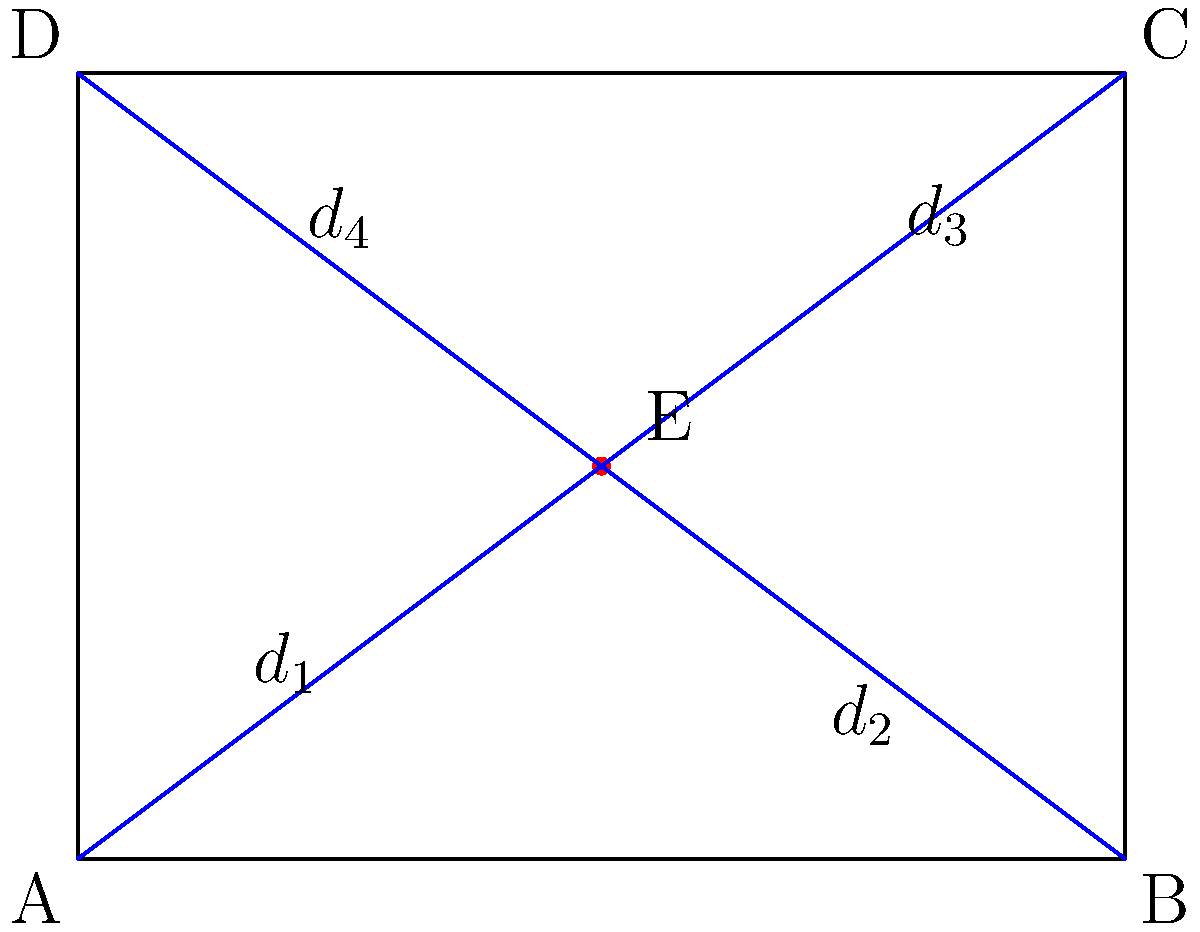You're planning to capture a panoramic view of a rectangular area using your RC aircraft equipped with open-source flight control software. The area measures 4 units wide and 3 units long. To ensure optimal coverage, you want to position your drone at a point E inside the rectangle that minimizes the sum of distances to all four corners. What are the coordinates of point E? To solve this problem, we'll follow these steps:

1) First, we need to understand that the point E we're looking for is the geometric median of the rectangle, also known as the Fermat point.

2) For a rectangle, the Fermat point is always at the intersection of the diagonals.

3) The diagonals of a rectangle always intersect at its center.

4) To find the center of the rectangle:
   - The x-coordinate will be halfway between 0 and 4: $(0 + 4) / 2 = 2$
   - The y-coordinate will be halfway between 0 and 3: $(0 + 3) / 2 = 1.5$

5) Therefore, the coordinates of point E are (2, 1.5).

This point E minimizes the sum of distances to all four corners (A, B, C, and D) of the rectangle, making it the optimal position for capturing a panoramic view of the entire area.
Answer: (2, 1.5) 